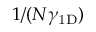Convert formula to latex. <formula><loc_0><loc_0><loc_500><loc_500>1 / ( N \gamma _ { 1 D } )</formula> 